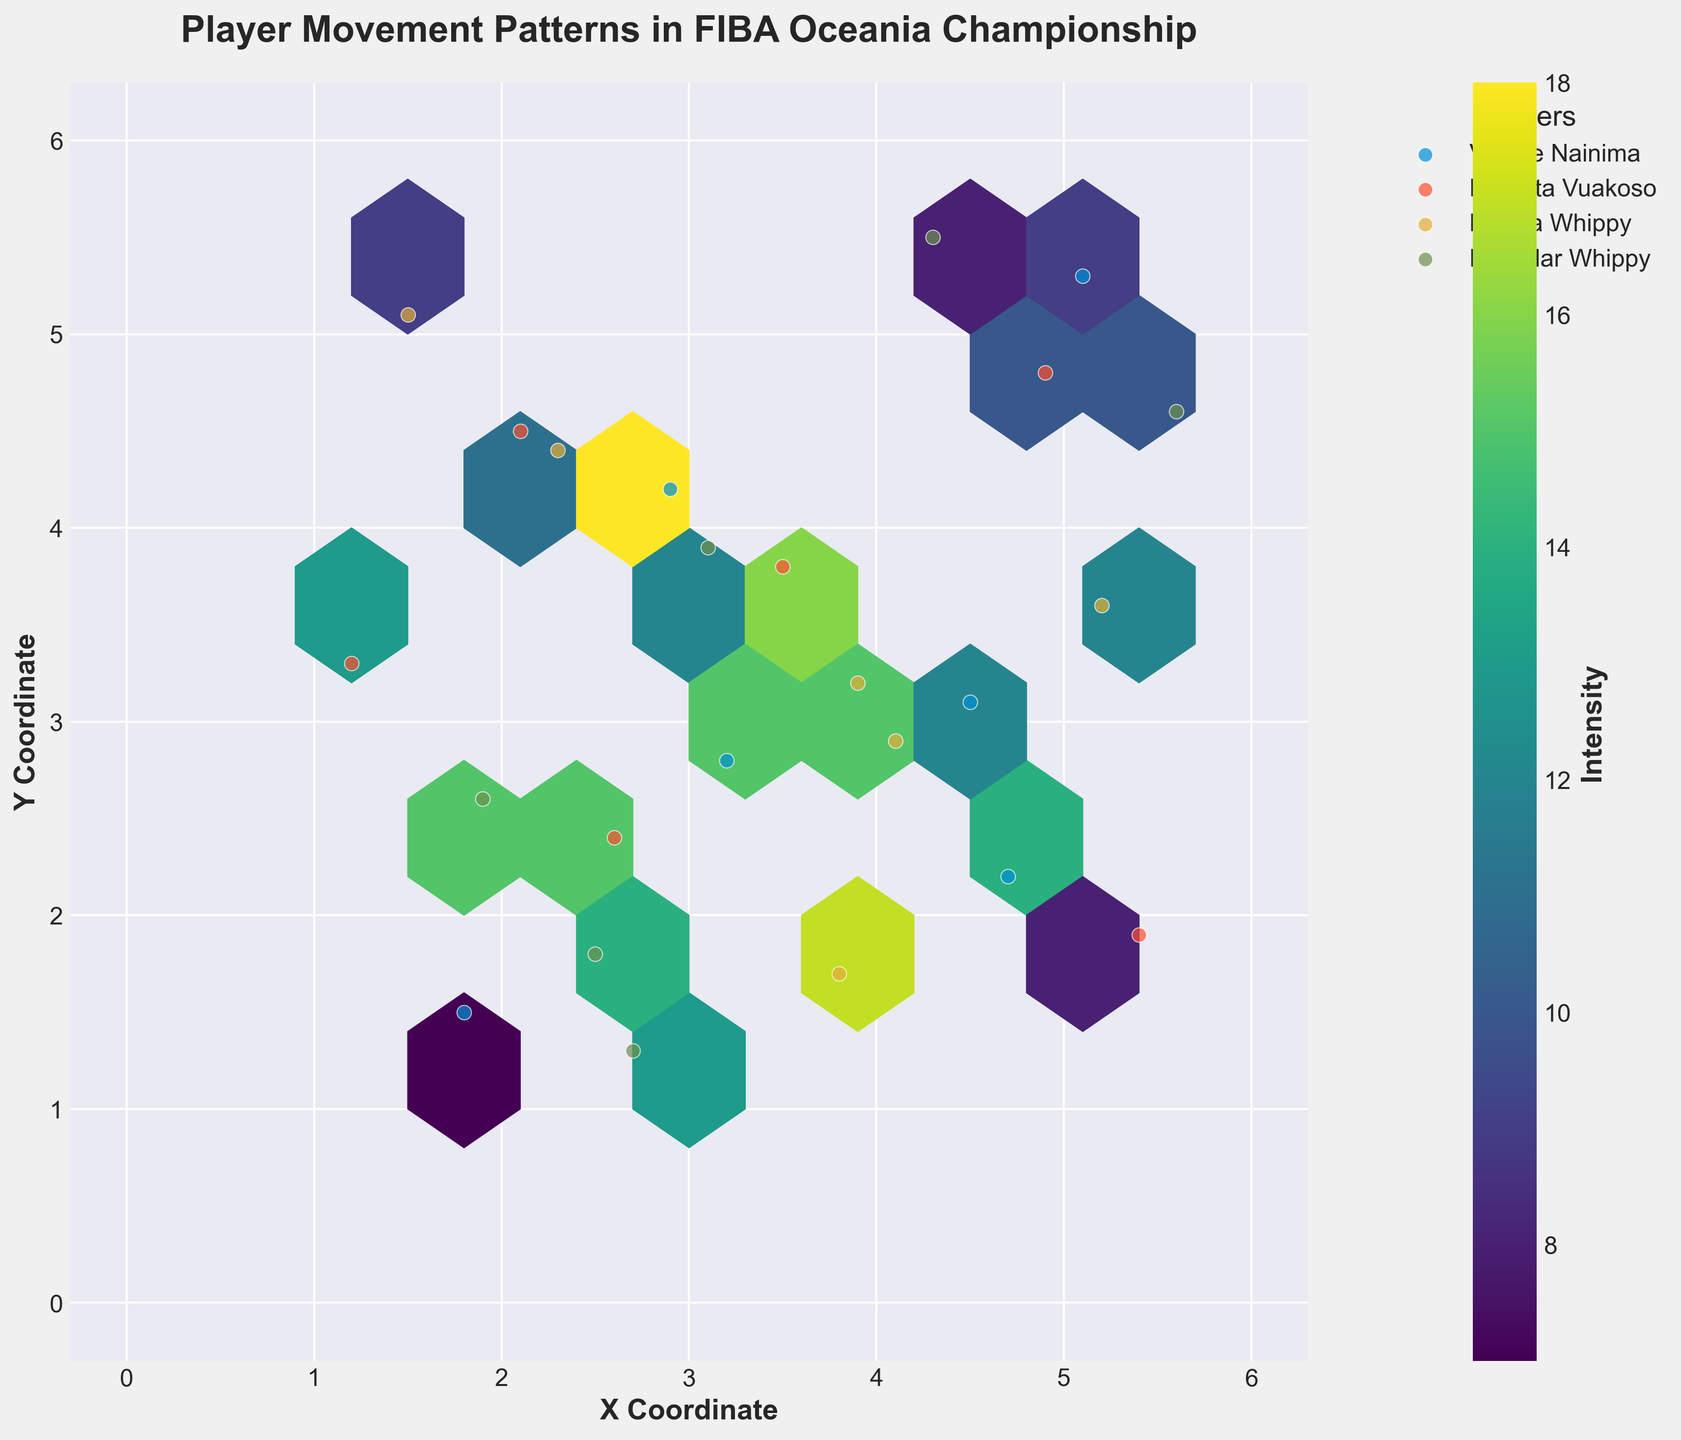What is the title of the hexbin plot? The title of the plot is displayed at the top of the figure.
Answer: Player Movement Patterns in FIBA Oceania Championship Which player has the data point with the highest intensity value, and what is that value? The highest intensity value can be found by identifying the peak value in the dataset and then matching it to the corresponding player in the plot. The highest value in the dataset is 18, associated with Valerie Nainima.
Answer: Valerie Nainima, 18 Where is Valerie Nainima most active on the court according to the plot? To determine where Valerie Nainima is most active, observe the hexbin plot for areas with high intensity values and where her name appears. The highest intensity value for Valerie Nainima is 18 at coordinates (2.9, 4.2).
Answer: Around coordinates (2.9, 4.2) Which player has most data points spread across the plot? To find which player has the most data points, check each player's presence across the plot. By observing, we can count the number of data points for each player. All players have 5 data points each.
Answer: All players have equal data points How does the intensity distribution for Matelita Vuakoso compare to that of Mikaelar Whippy? To compare the intensity distribution between Matelita Vuakoso and Mikaelar Whippy, observe the color intensity across their corresponding points on the hexbin plot. Matelita Vuakoso's intensities range from 8 to 17, while Mikaelar Whippy's range from 8 to 15.
Answer: Matelita Vuakoso has higher overall intensity values What range of x and y coordinates does Letava Whippy have the most activity? Observing Letava Whippy's data points and their color intensity on the hexbin plot, the most intense activity is found around coordinates with high intensity values. For Letava Whippy, the highest intensity (17) is near coordinate (3.8, 1.7).
Answer: (3.8, 1.7) Which player has the lowest intensity value, and what is that value? To find which player has the lowest intensity value, locate the minimum intensity value in the dataset and identify the player associated with it. The lowest intensity value is 7, associated with Valerie Nainima.
Answer: Valerie Nainima, 7 Between Valerie Nainima and Letava Whippy, who has more data points with intensity values above 10? By observing Valerie Nainima's and Letava Whippy's data points on the plot and counting the number of points with intensity values above 10, we see Valerie Nainima has four such points and Letava Whippy has five.
Answer: Letava Whippy What coordinate region has the highest concentration of data points? To find the region with the highest concentration of data points, observe the hexbin areas with the densest clustering and darkest colors indicating high intensity. The most concentrated area is around the region where multiple players have activity, notably around coordinates (1.8, 2.8) and (3.5, 3.8).
Answer: Around (3.5, 3.8) and (1.8, 2.8) 